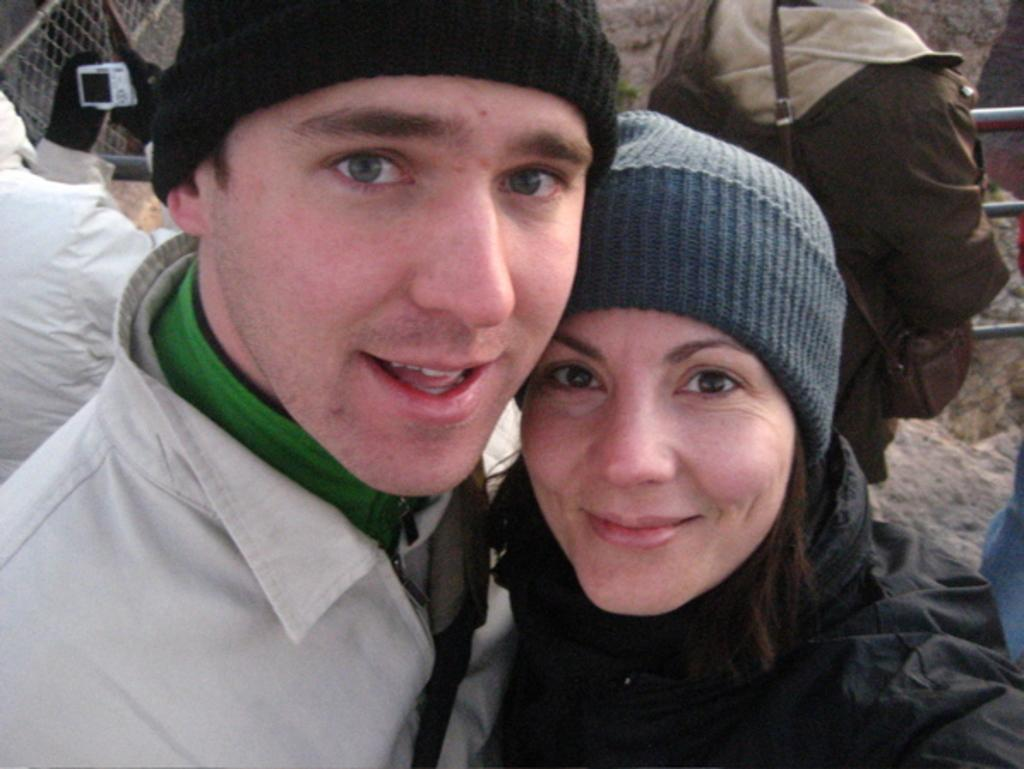How many people are in the image? There are two persons in the image. What are the persons wearing? The persons are wearing sweaters and caps. What are the persons doing in the image? The persons are posing for a photograph. What can be seen in the background of the image? There are people walking and fencing in the background of the image. What type of arithmetic problem can be solved using the honey in the image? There is no honey present in the image, so it cannot be used to solve any arithmetic problems. 